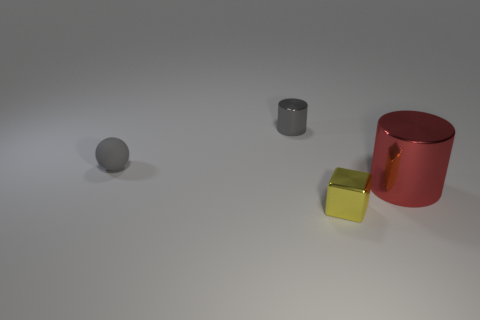Add 2 big things. How many objects exist? 6 Add 3 brown rubber cubes. How many brown rubber cubes exist? 3 Subtract all red cylinders. How many cylinders are left? 1 Subtract 0 yellow cylinders. How many objects are left? 4 Subtract all balls. How many objects are left? 3 Subtract 1 cylinders. How many cylinders are left? 1 Subtract all yellow spheres. Subtract all purple blocks. How many spheres are left? 1 Subtract all green cubes. How many blue cylinders are left? 0 Subtract all red cylinders. Subtract all tiny purple rubber objects. How many objects are left? 3 Add 3 big metal cylinders. How many big metal cylinders are left? 4 